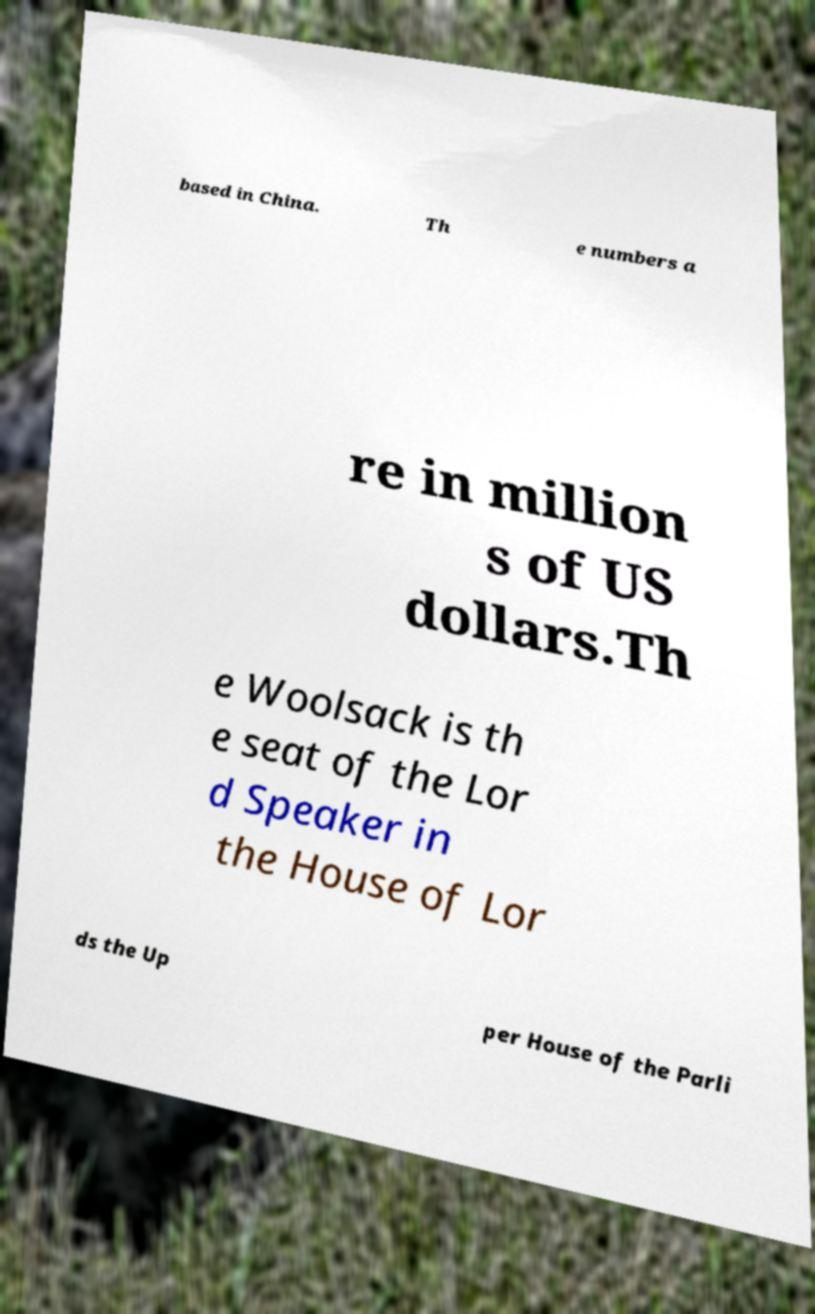I need the written content from this picture converted into text. Can you do that? based in China. Th e numbers a re in million s of US dollars.Th e Woolsack is th e seat of the Lor d Speaker in the House of Lor ds the Up per House of the Parli 